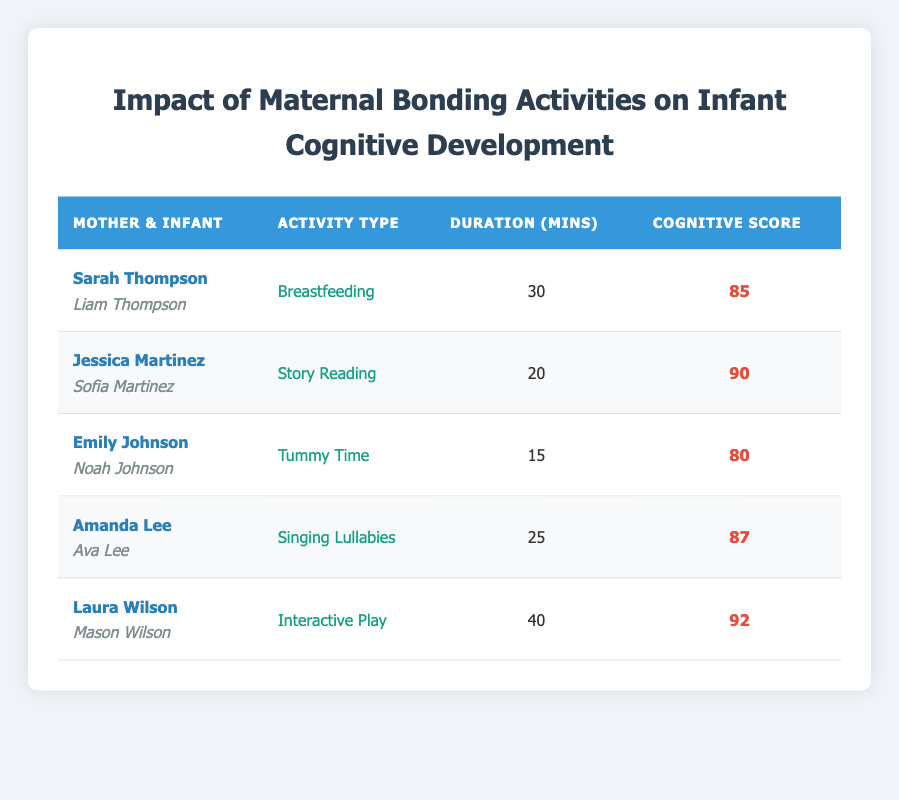What is the cognitive development score of Liam Thompson? The cognitive development score for Liam Thompson is listed directly under the 'Cognitive Score' column in the row corresponding to Sarah Thompson. The score is 85.
Answer: 85 Which activity type has the highest cognitive development score? The cognitive development scores are 85, 90, 80, 87, and 92. By comparing these values, the highest score is 92, which corresponds to the activity type 'Interactive Play' performed by Laura Wilson.
Answer: Interactive Play What is the total duration of activities for all infants combined? The durations for each activity are 30, 20, 15, 25, and 40 minutes. Adding these together gives (30 + 20 + 15 + 25 + 40) = 130 minutes.
Answer: 130 Is the cognitive development score of Sofia Martinez higher than that of Ava Lee? Sofia Martinez has a cognitive development score of 90, while Ava Lee has a score of 87. Since 90 is greater than 87, the statement is true.
Answer: Yes What is the average cognitive development score among the infants? The cognitive scores are 85, 90, 80, 87, and 92. The sum is (85 + 90 + 80 + 87 + 92) = 434. There are 5 scores, so the average is 434/5 = 86.8.
Answer: 86.8 How many minutes of maternal bonding activities are associated with the cognitive score of 92? The only score of 92 corresponds to 40 minutes of 'Interactive Play' conducted by Laura Wilson. Therefore, the activity duration linked to this score is 40 minutes.
Answer: 40 Is Emily Johnson the mother of an infant with the lowest cognitive development score? The lowest cognitive development score is 80, associated with Noah Johnson, who is the infant of Emily Johnson. Since this is the lowest score, the statement is true.
Answer: Yes What are the cognitive development scores for infants whose mothers engaged in singing lullabies and interactive play? The scores for 'Singing Lullabies' by Amanda Lee is 87, and for 'Interactive Play' by Laura Wilson it is 92. Therefore, the scores are 87 and 92 respectively.
Answer: 87 and 92 